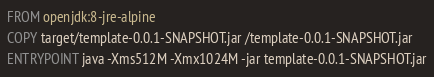Convert code to text. <code><loc_0><loc_0><loc_500><loc_500><_Dockerfile_>FROM openjdk:8-jre-alpine
COPY target/template-0.0.1-SNAPSHOT.jar /template-0.0.1-SNAPSHOT.jar
ENTRYPOINT java -Xms512M -Xmx1024M -jar template-0.0.1-SNAPSHOT.jar
</code> 